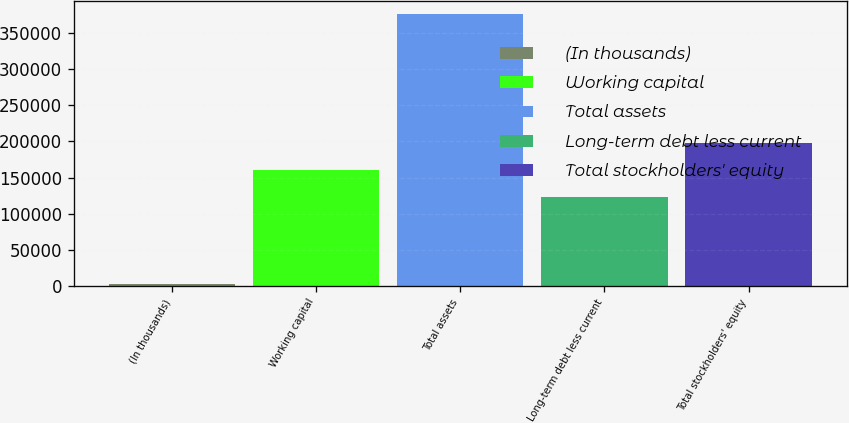Convert chart to OTSL. <chart><loc_0><loc_0><loc_500><loc_500><bar_chart><fcel>(In thousands)<fcel>Working capital<fcel>Total assets<fcel>Long-term debt less current<fcel>Total stockholders' equity<nl><fcel>2002<fcel>160669<fcel>376191<fcel>123250<fcel>198088<nl></chart> 